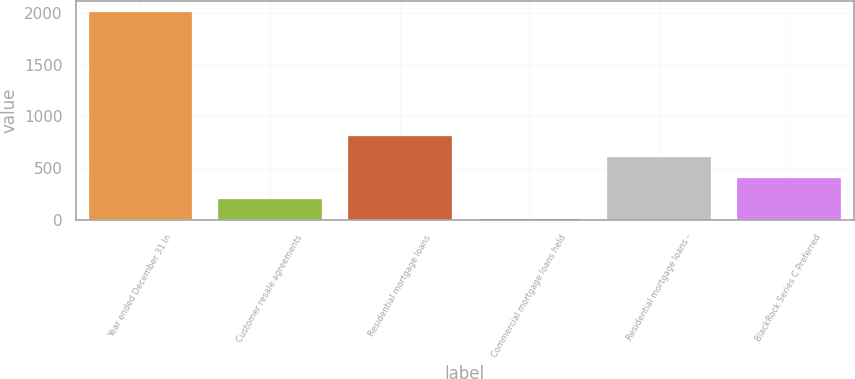Convert chart to OTSL. <chart><loc_0><loc_0><loc_500><loc_500><bar_chart><fcel>Year ended December 31 In<fcel>Customer resale agreements<fcel>Residential mortgage loans<fcel>Commercial mortgage loans held<fcel>Residential mortgage loans -<fcel>BlackRock Series C Preferred<nl><fcel>2012<fcel>205.7<fcel>807.8<fcel>5<fcel>607.1<fcel>406.4<nl></chart> 